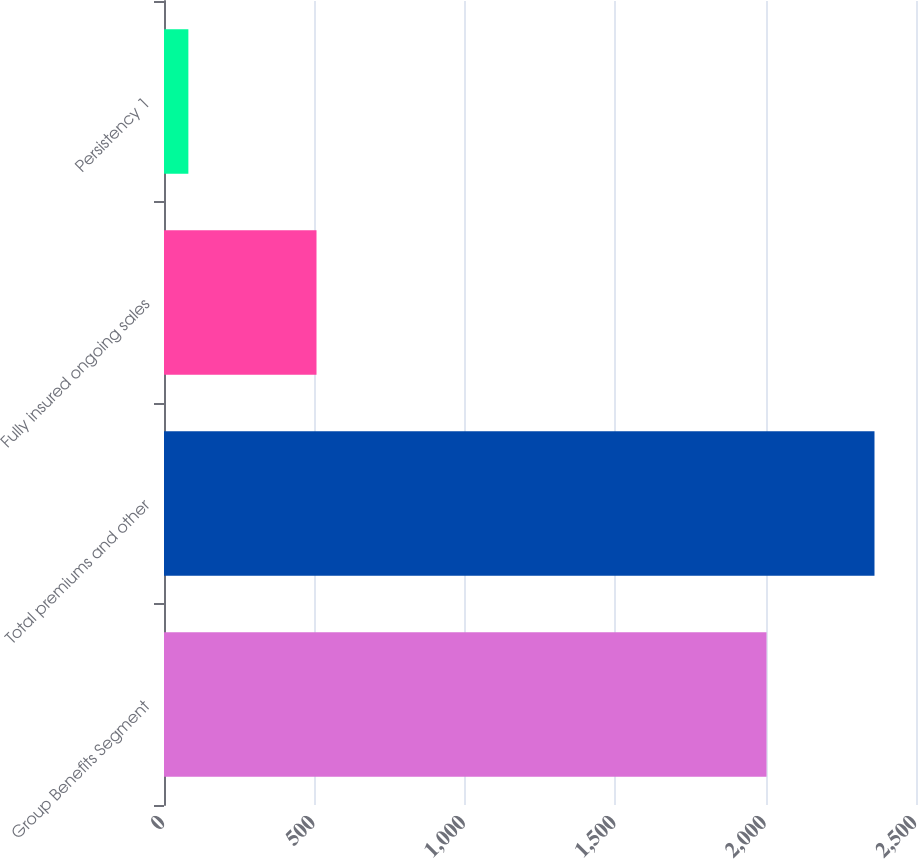Convert chart. <chart><loc_0><loc_0><loc_500><loc_500><bar_chart><fcel>Group Benefits Segment<fcel>Total premiums and other<fcel>Fully insured ongoing sales<fcel>Persistency 1<nl><fcel>2003<fcel>2362<fcel>507<fcel>81<nl></chart> 